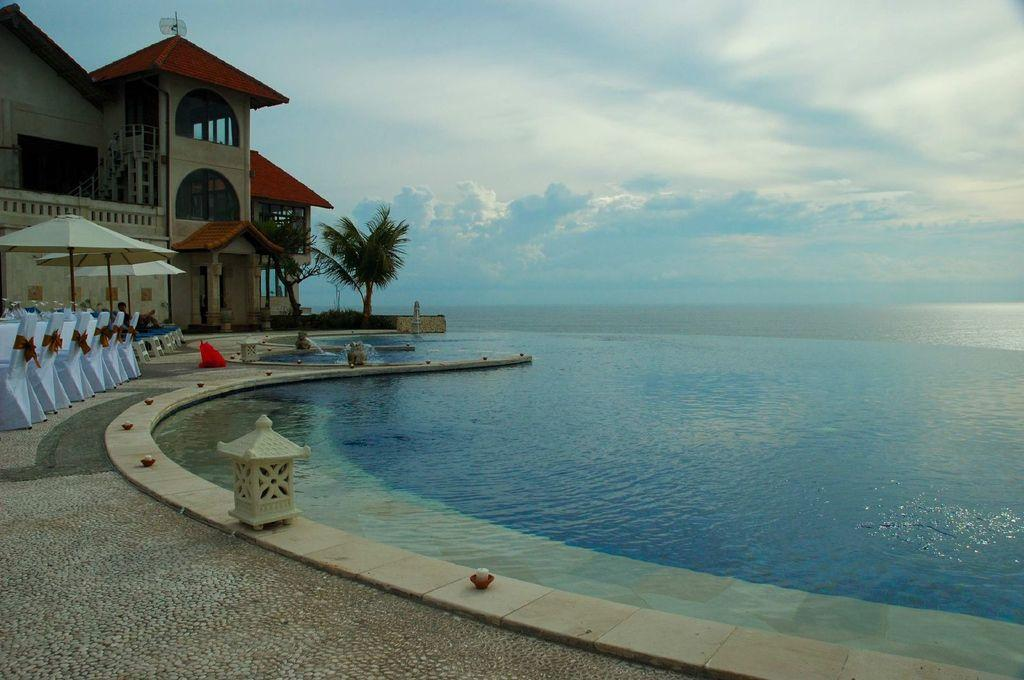What type of structure is visible in the image? There is a building in the image. What architectural feature can be seen in the image? There are stairs in the image. What type of vegetation is present in the image? There are trees in the image. What type of furniture is visible in the image? There are chairs in the image. What type of temporary shelter is present in the image? There are tents in the image. What recreational feature can be seen in the image? There is a pool in the image. What is the color of the sky in the image? The sky is blue and white in color. Can you find the receipt for the purchase of the vest in the image? There is no receipt or vest present in the image. Is the image a work of fiction or non-fiction? The image itself is neither fiction nor non-fiction; it is a photograph. 